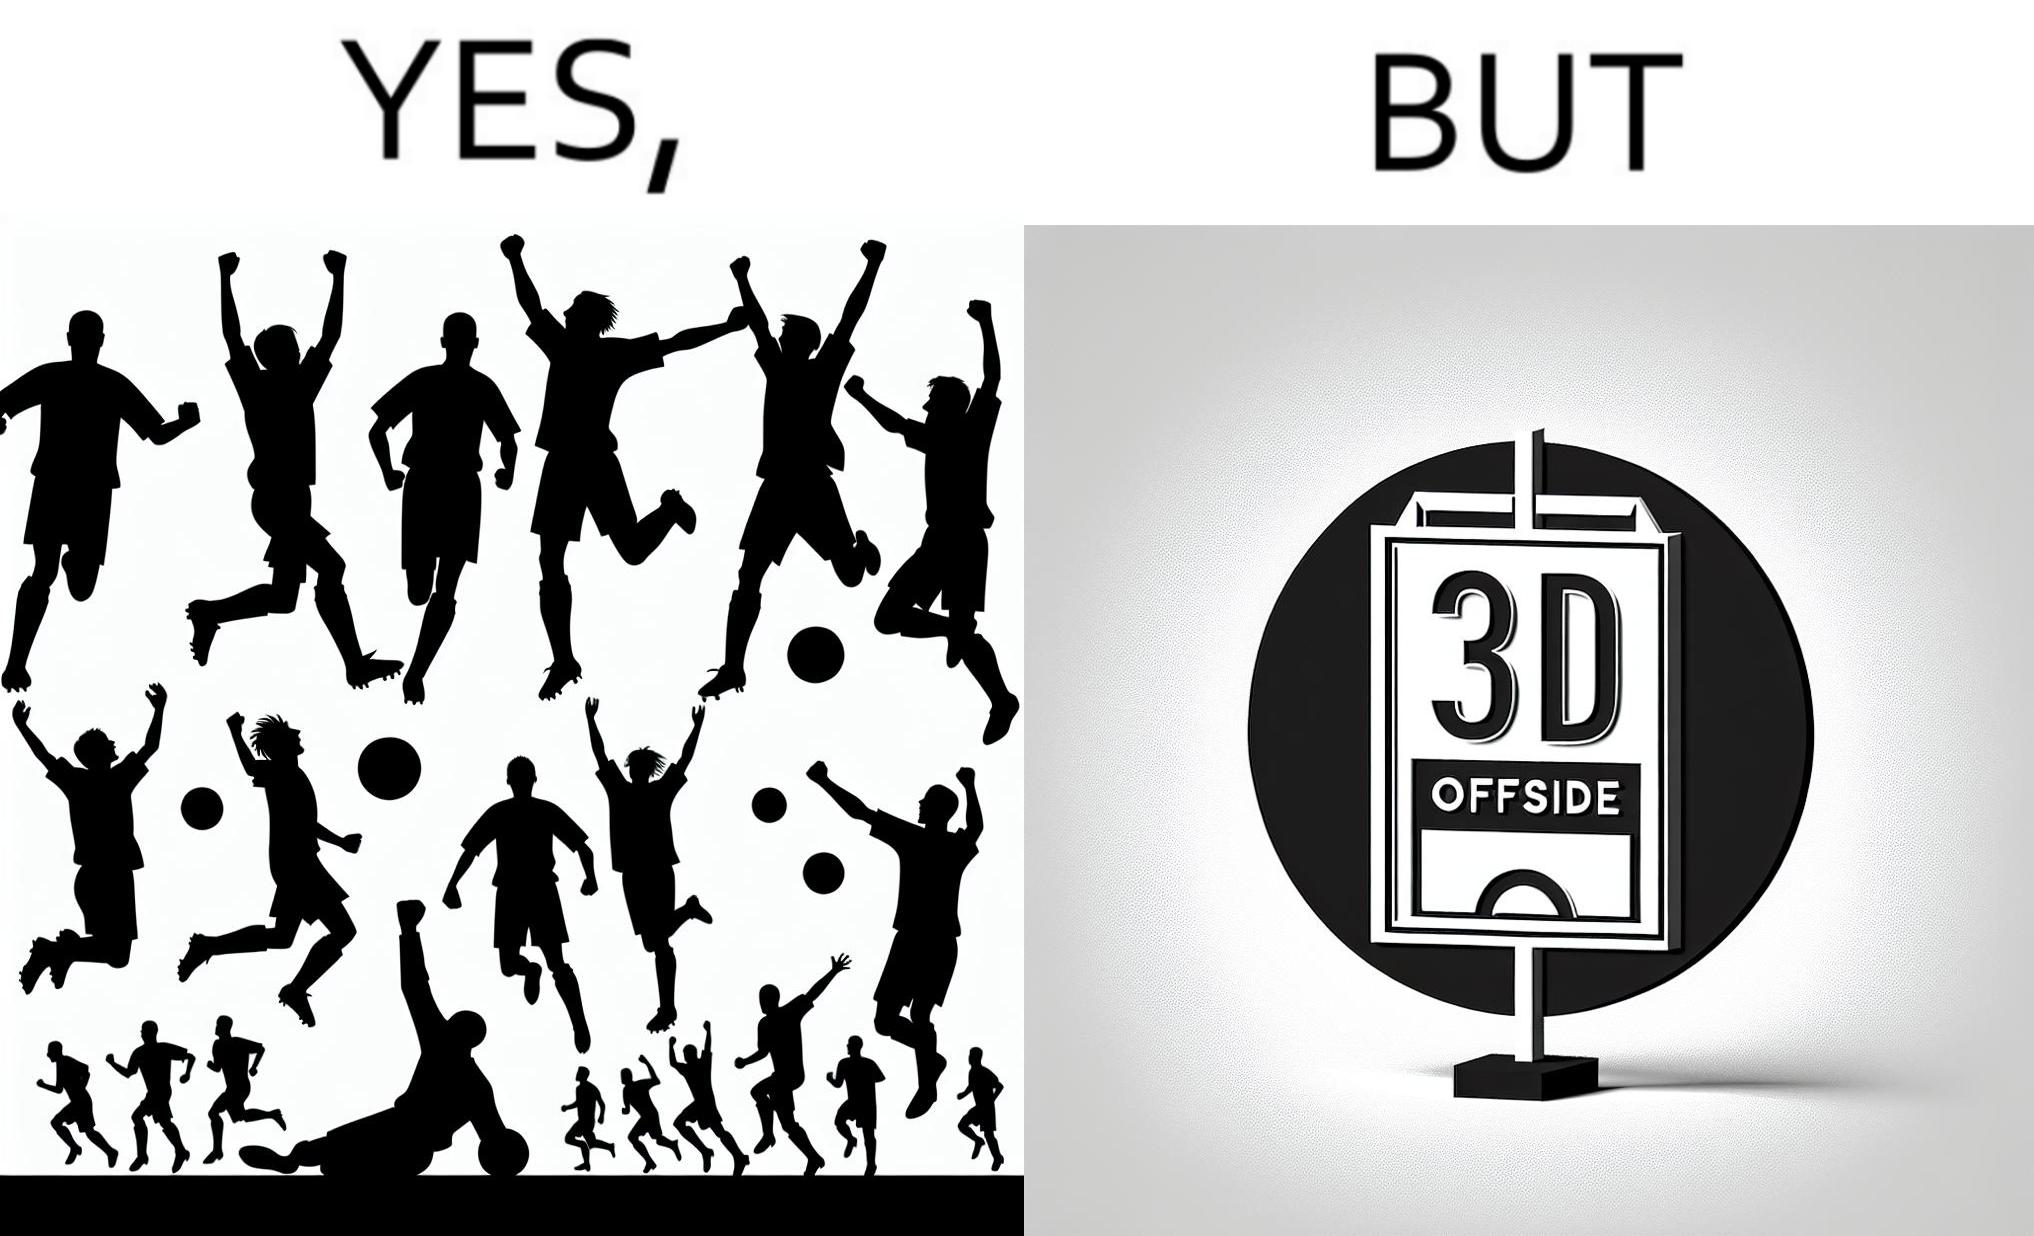Is this image satirical or non-satirical? Yes, this image is satirical. 